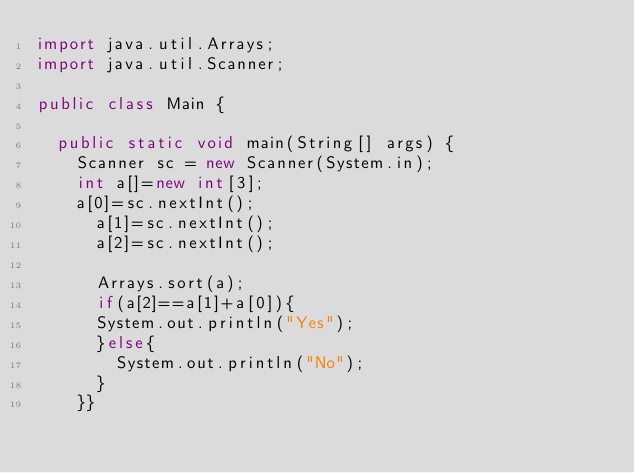<code> <loc_0><loc_0><loc_500><loc_500><_Java_>import java.util.Arrays;
import java.util.Scanner;

public class Main {

	public static void main(String[] args) {
		Scanner sc = new Scanner(System.in);
		int a[]=new int[3];
    a[0]=sc.nextInt();
      a[1]=sc.nextInt();
      a[2]=sc.nextInt();
      
      Arrays.sort(a);
      if(a[2]==a[1]+a[0]){
      System.out.println("Yes");
      }else{
        System.out.println("No");
      }
    }}
</code> 